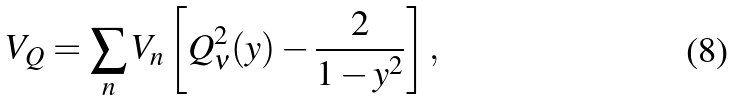<formula> <loc_0><loc_0><loc_500><loc_500>V _ { Q } = \sum _ { n } V _ { n } \left [ Q _ { \nu } ^ { 2 } ( y ) - \frac { 2 } { 1 - y ^ { 2 } } \right ] ,</formula> 